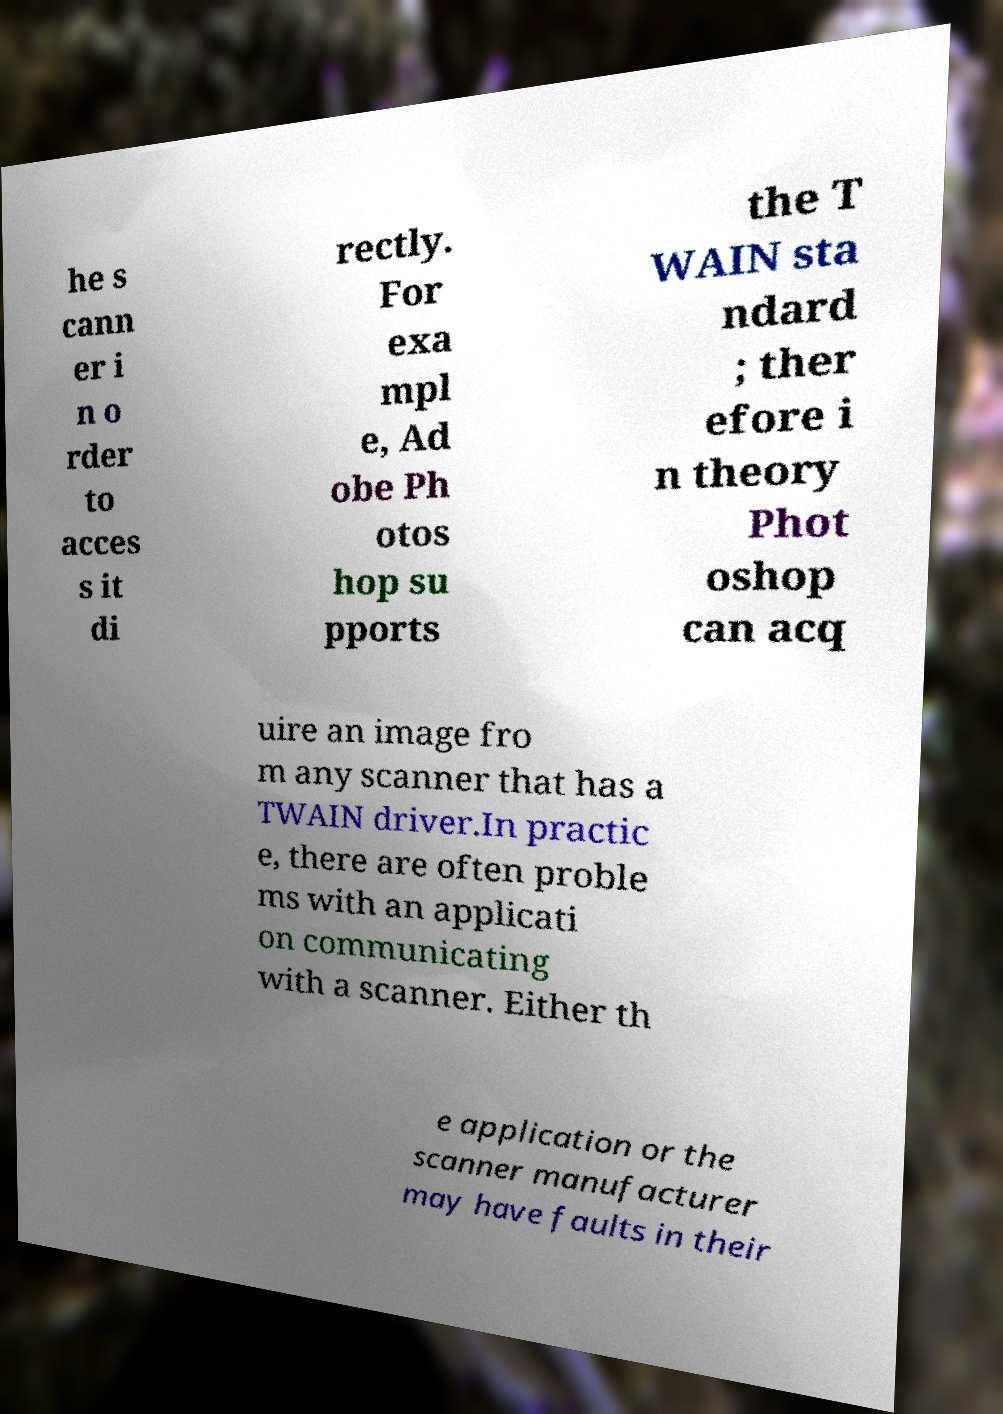I need the written content from this picture converted into text. Can you do that? he s cann er i n o rder to acces s it di rectly. For exa mpl e, Ad obe Ph otos hop su pports the T WAIN sta ndard ; ther efore i n theory Phot oshop can acq uire an image fro m any scanner that has a TWAIN driver.In practic e, there are often proble ms with an applicati on communicating with a scanner. Either th e application or the scanner manufacturer may have faults in their 